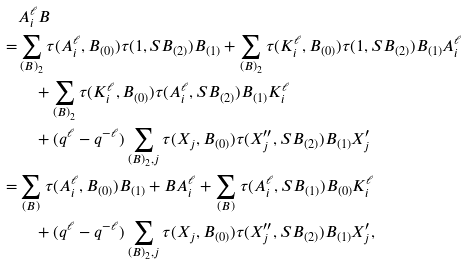Convert formula to latex. <formula><loc_0><loc_0><loc_500><loc_500>& A _ { i } ^ { \ell } B \\ = & \sum _ { ( B ) _ { 2 } } \tau ( A _ { i } ^ { \ell } , B _ { ( 0 ) } ) \tau ( 1 , S B _ { ( 2 ) } ) B _ { ( 1 ) } + \sum _ { ( B ) _ { 2 } } \tau ( K _ { i } ^ { \ell } , B _ { ( 0 ) } ) \tau ( 1 , S B _ { ( 2 ) } ) B _ { ( 1 ) } A _ { i } ^ { \ell } \\ & \quad + \sum _ { ( B ) _ { 2 } } \tau ( K _ { i } ^ { \ell } , B _ { ( 0 ) } ) \tau ( A _ { i } ^ { \ell } , S B _ { ( 2 ) } ) B _ { ( 1 ) } K _ { i } ^ { \ell } \\ & \quad + ( q ^ { \ell } - q ^ { - \ell } ) \sum _ { ( B ) _ { 2 } , j } \tau ( X _ { j } , B _ { ( 0 ) } ) \tau ( X _ { j } ^ { \prime \prime } , S B _ { ( 2 ) } ) B _ { ( 1 ) } X ^ { \prime } _ { j } \\ = & \sum _ { ( B ) } \tau ( A _ { i } ^ { \ell } , B _ { ( 0 ) } ) B _ { ( 1 ) } + B A _ { i } ^ { \ell } + \sum _ { ( B ) } \tau ( A _ { i } ^ { \ell } , S B _ { ( 1 ) } ) B _ { ( 0 ) } K _ { i } ^ { \ell } \\ & \quad + ( q ^ { \ell } - q ^ { - \ell } ) \sum _ { ( B ) _ { 2 } , j } \tau ( X _ { j } , B _ { ( 0 ) } ) \tau ( X _ { j } ^ { \prime \prime } , S B _ { ( 2 ) } ) B _ { ( 1 ) } X ^ { \prime } _ { j } ,</formula> 